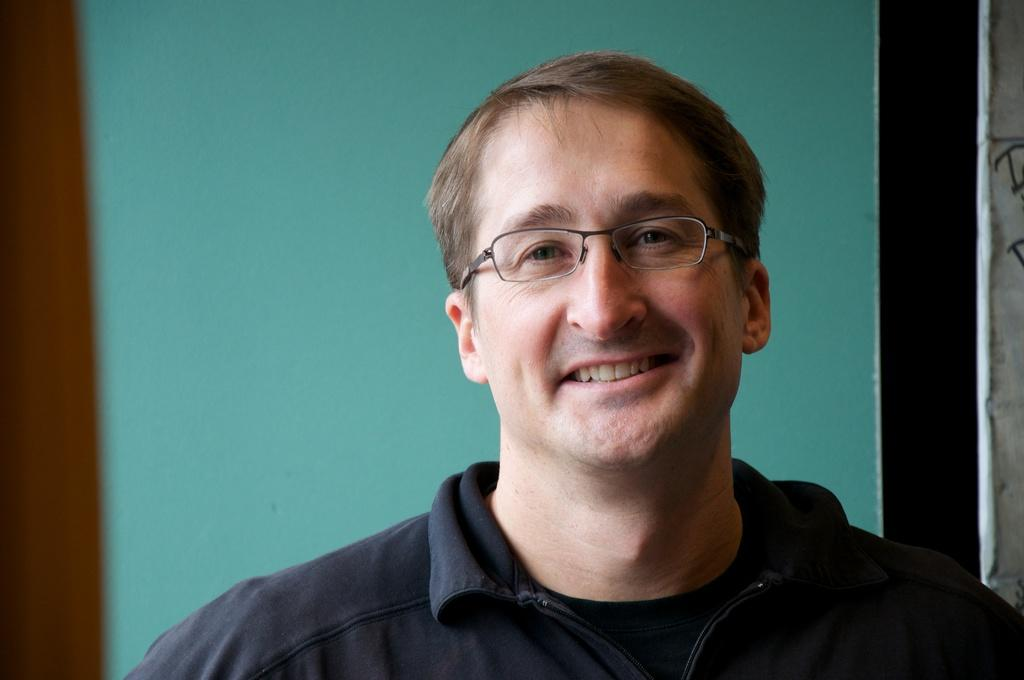Who is present in the image? There is a man in the image. What is the man's facial expression? The man is smiling. What is the man wearing in the image? The man is wearing a black jacket. What can be seen behind the man in the image? There is a wall visible behind the man. What type of dress is the visitor wearing in the image? There is no visitor present in the image, and therefore no dress can be observed. 